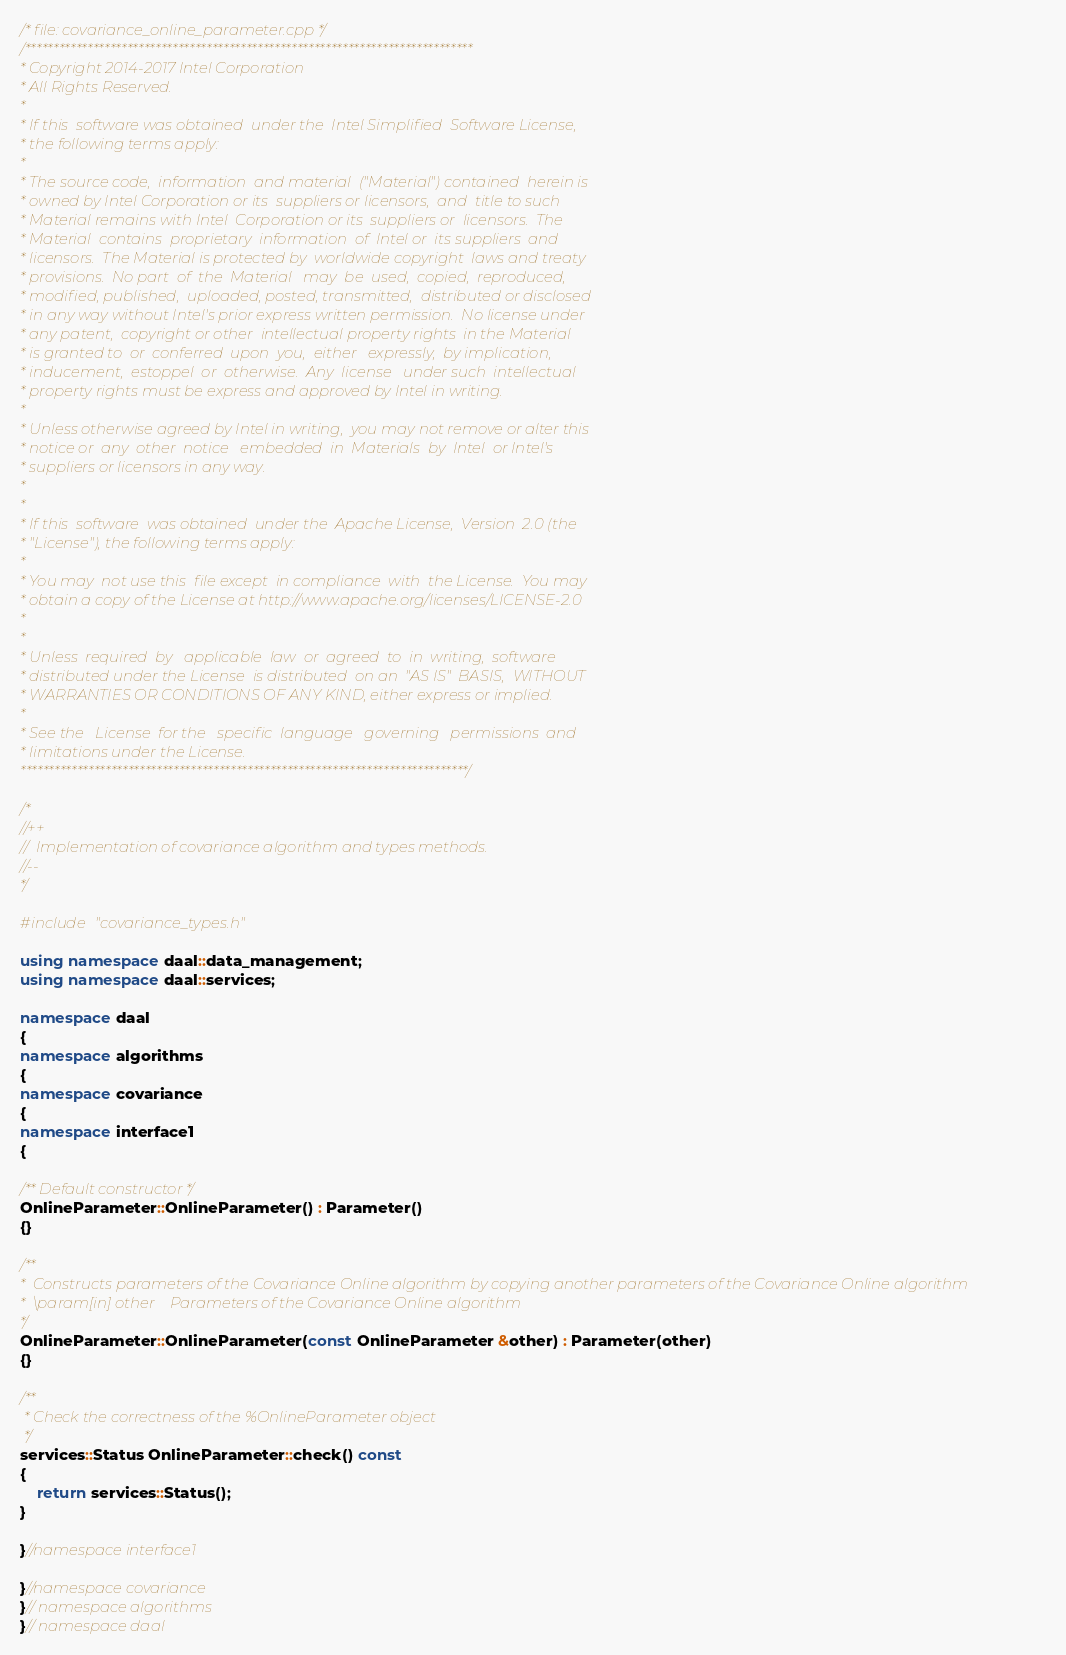<code> <loc_0><loc_0><loc_500><loc_500><_C++_>/* file: covariance_online_parameter.cpp */
/*******************************************************************************
* Copyright 2014-2017 Intel Corporation
* All Rights Reserved.
*
* If this  software was obtained  under the  Intel Simplified  Software License,
* the following terms apply:
*
* The source code,  information  and material  ("Material") contained  herein is
* owned by Intel Corporation or its  suppliers or licensors,  and  title to such
* Material remains with Intel  Corporation or its  suppliers or  licensors.  The
* Material  contains  proprietary  information  of  Intel or  its suppliers  and
* licensors.  The Material is protected by  worldwide copyright  laws and treaty
* provisions.  No part  of  the  Material   may  be  used,  copied,  reproduced,
* modified, published,  uploaded, posted, transmitted,  distributed or disclosed
* in any way without Intel's prior express written permission.  No license under
* any patent,  copyright or other  intellectual property rights  in the Material
* is granted to  or  conferred  upon  you,  either   expressly,  by implication,
* inducement,  estoppel  or  otherwise.  Any  license   under such  intellectual
* property rights must be express and approved by Intel in writing.
*
* Unless otherwise agreed by Intel in writing,  you may not remove or alter this
* notice or  any  other  notice   embedded  in  Materials  by  Intel  or Intel's
* suppliers or licensors in any way.
*
*
* If this  software  was obtained  under the  Apache License,  Version  2.0 (the
* "License"), the following terms apply:
*
* You may  not use this  file except  in compliance  with  the License.  You may
* obtain a copy of the License at http://www.apache.org/licenses/LICENSE-2.0
*
*
* Unless  required  by   applicable  law  or  agreed  to  in  writing,  software
* distributed under the License  is distributed  on an  "AS IS"  BASIS,  WITHOUT
* WARRANTIES OR CONDITIONS OF ANY KIND, either express or implied.
*
* See the   License  for the   specific  language   governing   permissions  and
* limitations under the License.
*******************************************************************************/

/*
//++
//  Implementation of covariance algorithm and types methods.
//--
*/

#include "covariance_types.h"

using namespace daal::data_management;
using namespace daal::services;

namespace daal
{
namespace algorithms
{
namespace covariance
{
namespace interface1
{

/** Default constructor */
OnlineParameter::OnlineParameter() : Parameter()
{}

/**
*  Constructs parameters of the Covariance Online algorithm by copying another parameters of the Covariance Online algorithm
*  \param[in] other    Parameters of the Covariance Online algorithm
*/
OnlineParameter::OnlineParameter(const OnlineParameter &other) : Parameter(other)
{}

/**
 * Check the correctness of the %OnlineParameter object
 */
services::Status OnlineParameter::check() const
{
    return services::Status();
}

}//namespace interface1

}//namespace covariance
}// namespace algorithms
}// namespace daal
</code> 